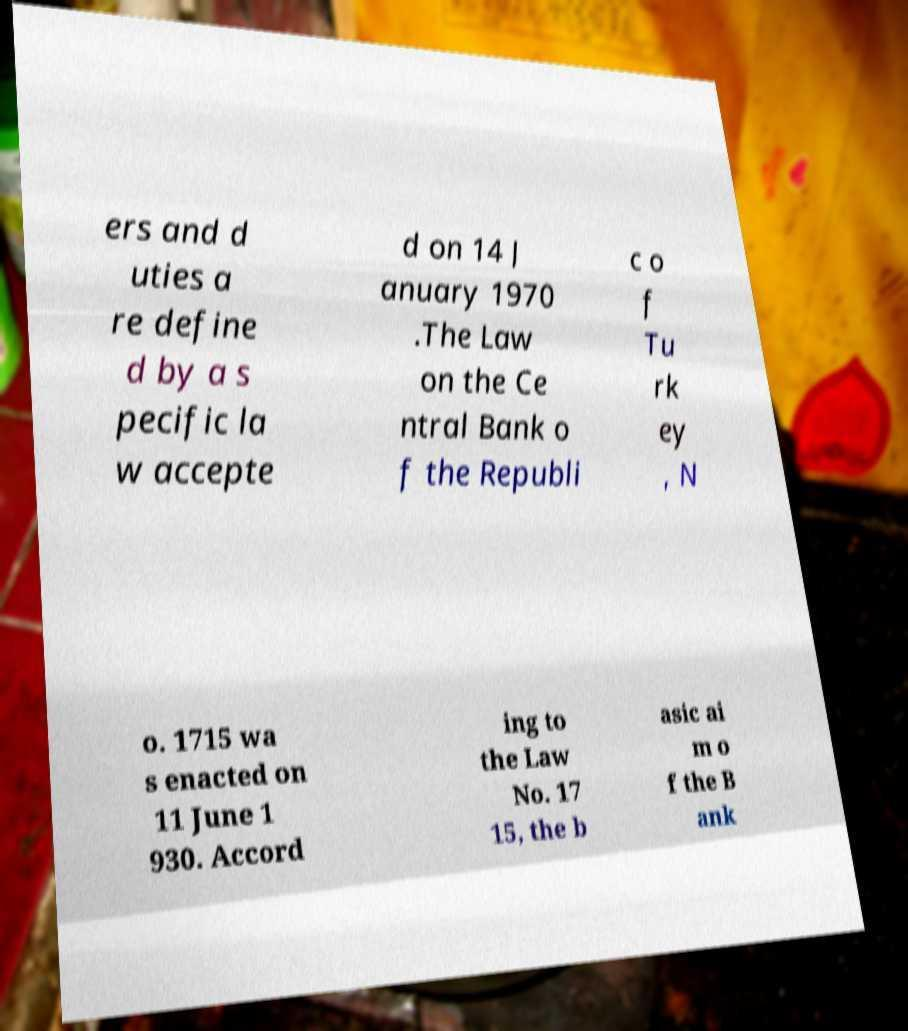I need the written content from this picture converted into text. Can you do that? ers and d uties a re define d by a s pecific la w accepte d on 14 J anuary 1970 .The Law on the Ce ntral Bank o f the Republi c o f Tu rk ey , N o. 1715 wa s enacted on 11 June 1 930. Accord ing to the Law No. 17 15, the b asic ai m o f the B ank 